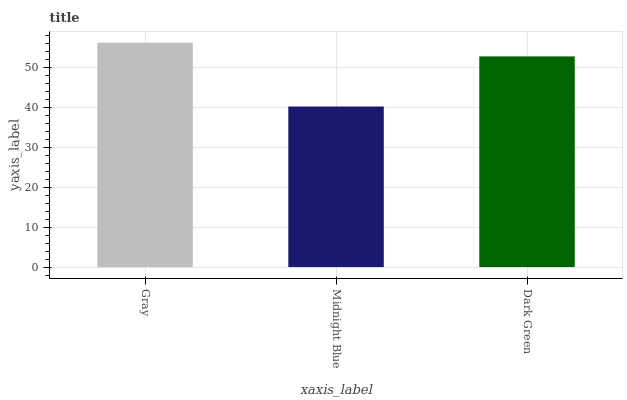Is Dark Green the minimum?
Answer yes or no. No. Is Dark Green the maximum?
Answer yes or no. No. Is Dark Green greater than Midnight Blue?
Answer yes or no. Yes. Is Midnight Blue less than Dark Green?
Answer yes or no. Yes. Is Midnight Blue greater than Dark Green?
Answer yes or no. No. Is Dark Green less than Midnight Blue?
Answer yes or no. No. Is Dark Green the high median?
Answer yes or no. Yes. Is Dark Green the low median?
Answer yes or no. Yes. Is Gray the high median?
Answer yes or no. No. Is Midnight Blue the low median?
Answer yes or no. No. 